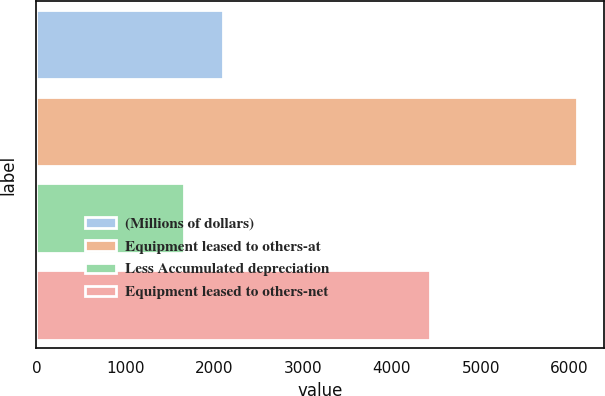Convert chart. <chart><loc_0><loc_0><loc_500><loc_500><bar_chart><fcel>(Millions of dollars)<fcel>Equipment leased to others-at<fcel>Less Accumulated depreciation<fcel>Equipment leased to others-net<nl><fcel>2101.7<fcel>6086<fcel>1659<fcel>4427<nl></chart> 